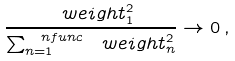Convert formula to latex. <formula><loc_0><loc_0><loc_500><loc_500>\frac { \ w e i g h t _ { 1 } ^ { 2 } } { \sum _ { n = 1 } ^ { \ n f u n c } \ w e i g h t _ { n } ^ { 2 } } \to 0 \, ,</formula> 